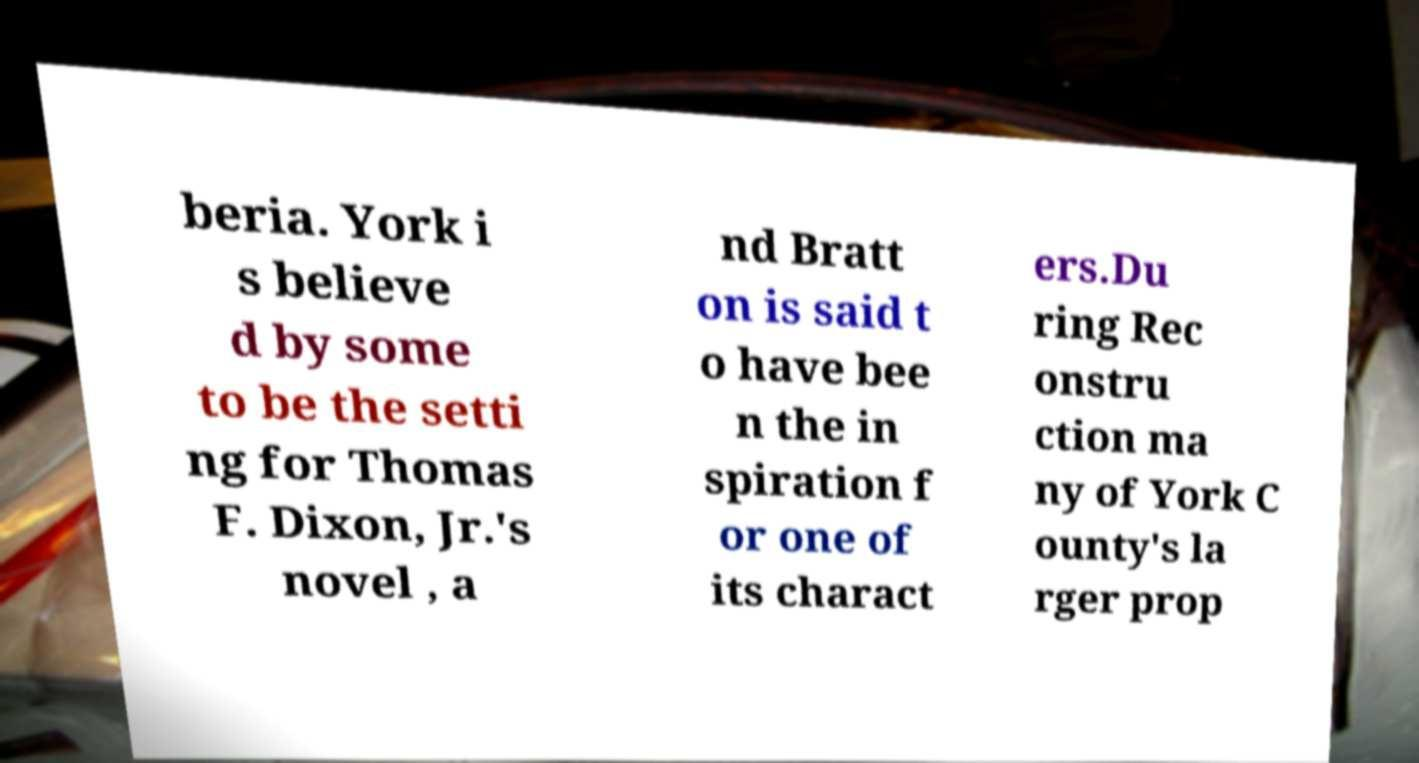Could you extract and type out the text from this image? beria. York i s believe d by some to be the setti ng for Thomas F. Dixon, Jr.'s novel , a nd Bratt on is said t o have bee n the in spiration f or one of its charact ers.Du ring Rec onstru ction ma ny of York C ounty's la rger prop 